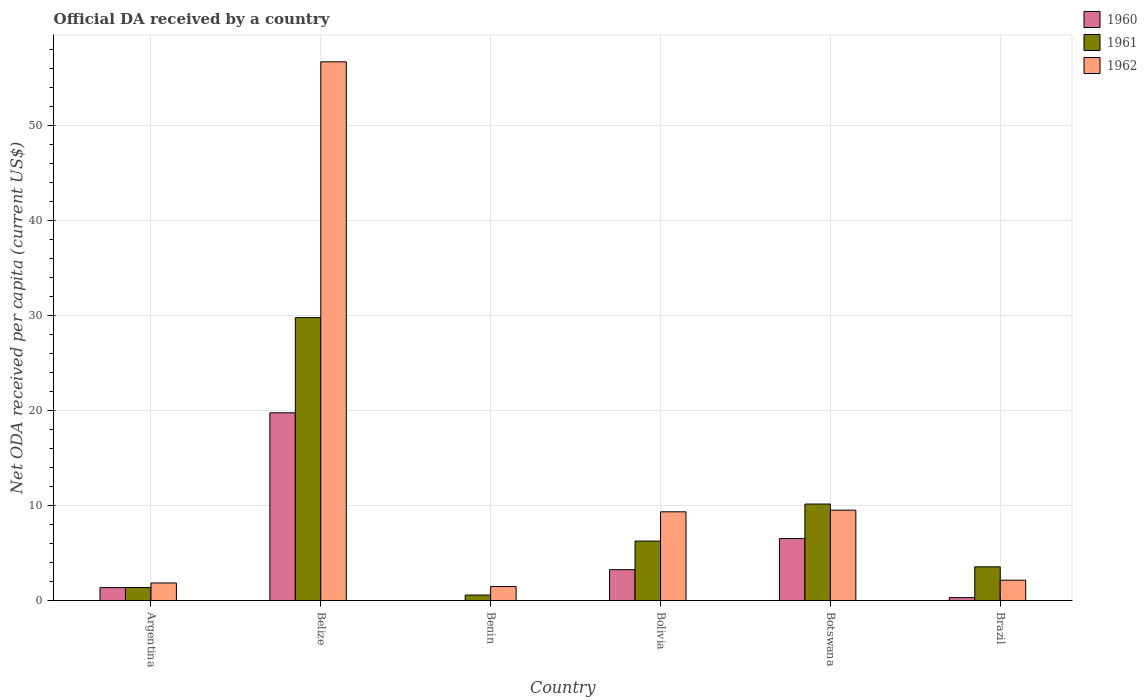Are the number of bars per tick equal to the number of legend labels?
Your answer should be compact. Yes. How many bars are there on the 6th tick from the left?
Provide a short and direct response. 3. What is the label of the 2nd group of bars from the left?
Make the answer very short. Belize. In how many cases, is the number of bars for a given country not equal to the number of legend labels?
Provide a short and direct response. 0. What is the ODA received in in 1961 in Botswana?
Offer a very short reply. 10.18. Across all countries, what is the maximum ODA received in in 1960?
Provide a short and direct response. 19.77. Across all countries, what is the minimum ODA received in in 1962?
Make the answer very short. 1.5. In which country was the ODA received in in 1960 maximum?
Your response must be concise. Belize. In which country was the ODA received in in 1961 minimum?
Your response must be concise. Benin. What is the total ODA received in in 1962 in the graph?
Keep it short and to the point. 81.09. What is the difference between the ODA received in in 1961 in Benin and that in Brazil?
Your answer should be compact. -2.97. What is the difference between the ODA received in in 1961 in Brazil and the ODA received in in 1960 in Bolivia?
Offer a very short reply. 0.3. What is the average ODA received in in 1960 per country?
Offer a very short reply. 5.22. What is the difference between the ODA received in of/in 1962 and ODA received in of/in 1960 in Brazil?
Give a very brief answer. 1.83. In how many countries, is the ODA received in in 1962 greater than 8 US$?
Offer a terse response. 3. What is the ratio of the ODA received in in 1962 in Benin to that in Brazil?
Keep it short and to the point. 0.69. Is the ODA received in in 1961 in Belize less than that in Brazil?
Make the answer very short. No. What is the difference between the highest and the second highest ODA received in in 1961?
Provide a short and direct response. -19.6. What is the difference between the highest and the lowest ODA received in in 1960?
Provide a succinct answer. 19.76. In how many countries, is the ODA received in in 1962 greater than the average ODA received in in 1962 taken over all countries?
Give a very brief answer. 1. Is the sum of the ODA received in in 1962 in Botswana and Brazil greater than the maximum ODA received in in 1960 across all countries?
Provide a succinct answer. No. What does the 3rd bar from the right in Botswana represents?
Provide a short and direct response. 1960. Is it the case that in every country, the sum of the ODA received in in 1961 and ODA received in in 1960 is greater than the ODA received in in 1962?
Provide a succinct answer. No. Are all the bars in the graph horizontal?
Make the answer very short. No. How many countries are there in the graph?
Keep it short and to the point. 6. What is the difference between two consecutive major ticks on the Y-axis?
Ensure brevity in your answer.  10. Are the values on the major ticks of Y-axis written in scientific E-notation?
Offer a very short reply. No. Does the graph contain any zero values?
Your answer should be compact. No. Where does the legend appear in the graph?
Keep it short and to the point. Top right. How many legend labels are there?
Ensure brevity in your answer.  3. What is the title of the graph?
Ensure brevity in your answer.  Official DA received by a country. Does "1975" appear as one of the legend labels in the graph?
Provide a succinct answer. No. What is the label or title of the Y-axis?
Give a very brief answer. Net ODA received per capita (current US$). What is the Net ODA received per capita (current US$) in 1960 in Argentina?
Provide a succinct answer. 1.39. What is the Net ODA received per capita (current US$) of 1961 in Argentina?
Keep it short and to the point. 1.39. What is the Net ODA received per capita (current US$) of 1962 in Argentina?
Offer a very short reply. 1.87. What is the Net ODA received per capita (current US$) of 1960 in Belize?
Provide a succinct answer. 19.77. What is the Net ODA received per capita (current US$) of 1961 in Belize?
Keep it short and to the point. 29.78. What is the Net ODA received per capita (current US$) in 1962 in Belize?
Keep it short and to the point. 56.68. What is the Net ODA received per capita (current US$) of 1960 in Benin?
Your answer should be compact. 0.01. What is the Net ODA received per capita (current US$) in 1961 in Benin?
Make the answer very short. 0.6. What is the Net ODA received per capita (current US$) in 1962 in Benin?
Offer a very short reply. 1.5. What is the Net ODA received per capita (current US$) of 1960 in Bolivia?
Your answer should be compact. 3.27. What is the Net ODA received per capita (current US$) in 1961 in Bolivia?
Provide a short and direct response. 6.28. What is the Net ODA received per capita (current US$) in 1962 in Bolivia?
Provide a succinct answer. 9.36. What is the Net ODA received per capita (current US$) in 1960 in Botswana?
Your answer should be compact. 6.55. What is the Net ODA received per capita (current US$) of 1961 in Botswana?
Make the answer very short. 10.18. What is the Net ODA received per capita (current US$) of 1962 in Botswana?
Provide a short and direct response. 9.53. What is the Net ODA received per capita (current US$) in 1960 in Brazil?
Offer a terse response. 0.33. What is the Net ODA received per capita (current US$) of 1961 in Brazil?
Provide a succinct answer. 3.57. What is the Net ODA received per capita (current US$) in 1962 in Brazil?
Provide a short and direct response. 2.16. Across all countries, what is the maximum Net ODA received per capita (current US$) of 1960?
Keep it short and to the point. 19.77. Across all countries, what is the maximum Net ODA received per capita (current US$) of 1961?
Offer a terse response. 29.78. Across all countries, what is the maximum Net ODA received per capita (current US$) in 1962?
Your answer should be compact. 56.68. Across all countries, what is the minimum Net ODA received per capita (current US$) in 1960?
Give a very brief answer. 0.01. Across all countries, what is the minimum Net ODA received per capita (current US$) of 1961?
Offer a very short reply. 0.6. Across all countries, what is the minimum Net ODA received per capita (current US$) in 1962?
Provide a succinct answer. 1.5. What is the total Net ODA received per capita (current US$) of 1960 in the graph?
Your response must be concise. 31.31. What is the total Net ODA received per capita (current US$) of 1961 in the graph?
Offer a terse response. 51.79. What is the total Net ODA received per capita (current US$) in 1962 in the graph?
Offer a very short reply. 81.09. What is the difference between the Net ODA received per capita (current US$) in 1960 in Argentina and that in Belize?
Offer a very short reply. -18.38. What is the difference between the Net ODA received per capita (current US$) of 1961 in Argentina and that in Belize?
Offer a terse response. -28.39. What is the difference between the Net ODA received per capita (current US$) of 1962 in Argentina and that in Belize?
Provide a short and direct response. -54.81. What is the difference between the Net ODA received per capita (current US$) in 1960 in Argentina and that in Benin?
Keep it short and to the point. 1.38. What is the difference between the Net ODA received per capita (current US$) of 1961 in Argentina and that in Benin?
Your answer should be compact. 0.79. What is the difference between the Net ODA received per capita (current US$) in 1962 in Argentina and that in Benin?
Provide a short and direct response. 0.37. What is the difference between the Net ODA received per capita (current US$) of 1960 in Argentina and that in Bolivia?
Your answer should be compact. -1.88. What is the difference between the Net ODA received per capita (current US$) of 1961 in Argentina and that in Bolivia?
Offer a terse response. -4.88. What is the difference between the Net ODA received per capita (current US$) in 1962 in Argentina and that in Bolivia?
Your answer should be very brief. -7.49. What is the difference between the Net ODA received per capita (current US$) in 1960 in Argentina and that in Botswana?
Your response must be concise. -5.16. What is the difference between the Net ODA received per capita (current US$) of 1961 in Argentina and that in Botswana?
Offer a very short reply. -8.78. What is the difference between the Net ODA received per capita (current US$) in 1962 in Argentina and that in Botswana?
Your answer should be very brief. -7.66. What is the difference between the Net ODA received per capita (current US$) of 1960 in Argentina and that in Brazil?
Provide a short and direct response. 1.05. What is the difference between the Net ODA received per capita (current US$) in 1961 in Argentina and that in Brazil?
Make the answer very short. -2.18. What is the difference between the Net ODA received per capita (current US$) in 1962 in Argentina and that in Brazil?
Your response must be concise. -0.29. What is the difference between the Net ODA received per capita (current US$) of 1960 in Belize and that in Benin?
Your response must be concise. 19.76. What is the difference between the Net ODA received per capita (current US$) of 1961 in Belize and that in Benin?
Keep it short and to the point. 29.18. What is the difference between the Net ODA received per capita (current US$) in 1962 in Belize and that in Benin?
Make the answer very short. 55.18. What is the difference between the Net ODA received per capita (current US$) of 1960 in Belize and that in Bolivia?
Offer a terse response. 16.5. What is the difference between the Net ODA received per capita (current US$) of 1961 in Belize and that in Bolivia?
Provide a succinct answer. 23.5. What is the difference between the Net ODA received per capita (current US$) of 1962 in Belize and that in Bolivia?
Provide a short and direct response. 47.32. What is the difference between the Net ODA received per capita (current US$) in 1960 in Belize and that in Botswana?
Offer a very short reply. 13.22. What is the difference between the Net ODA received per capita (current US$) of 1961 in Belize and that in Botswana?
Give a very brief answer. 19.6. What is the difference between the Net ODA received per capita (current US$) of 1962 in Belize and that in Botswana?
Make the answer very short. 47.15. What is the difference between the Net ODA received per capita (current US$) of 1960 in Belize and that in Brazil?
Offer a terse response. 19.44. What is the difference between the Net ODA received per capita (current US$) in 1961 in Belize and that in Brazil?
Your response must be concise. 26.21. What is the difference between the Net ODA received per capita (current US$) of 1962 in Belize and that in Brazil?
Offer a very short reply. 54.52. What is the difference between the Net ODA received per capita (current US$) in 1960 in Benin and that in Bolivia?
Ensure brevity in your answer.  -3.26. What is the difference between the Net ODA received per capita (current US$) in 1961 in Benin and that in Bolivia?
Provide a short and direct response. -5.68. What is the difference between the Net ODA received per capita (current US$) of 1962 in Benin and that in Bolivia?
Your answer should be very brief. -7.86. What is the difference between the Net ODA received per capita (current US$) in 1960 in Benin and that in Botswana?
Keep it short and to the point. -6.54. What is the difference between the Net ODA received per capita (current US$) of 1961 in Benin and that in Botswana?
Your answer should be very brief. -9.58. What is the difference between the Net ODA received per capita (current US$) in 1962 in Benin and that in Botswana?
Your answer should be very brief. -8.03. What is the difference between the Net ODA received per capita (current US$) of 1960 in Benin and that in Brazil?
Give a very brief answer. -0.32. What is the difference between the Net ODA received per capita (current US$) of 1961 in Benin and that in Brazil?
Offer a very short reply. -2.97. What is the difference between the Net ODA received per capita (current US$) of 1962 in Benin and that in Brazil?
Make the answer very short. -0.66. What is the difference between the Net ODA received per capita (current US$) of 1960 in Bolivia and that in Botswana?
Your answer should be compact. -3.27. What is the difference between the Net ODA received per capita (current US$) in 1961 in Bolivia and that in Botswana?
Ensure brevity in your answer.  -3.9. What is the difference between the Net ODA received per capita (current US$) in 1962 in Bolivia and that in Botswana?
Your answer should be very brief. -0.17. What is the difference between the Net ODA received per capita (current US$) in 1960 in Bolivia and that in Brazil?
Provide a succinct answer. 2.94. What is the difference between the Net ODA received per capita (current US$) of 1961 in Bolivia and that in Brazil?
Your answer should be compact. 2.71. What is the difference between the Net ODA received per capita (current US$) of 1962 in Bolivia and that in Brazil?
Provide a short and direct response. 7.19. What is the difference between the Net ODA received per capita (current US$) in 1960 in Botswana and that in Brazil?
Provide a short and direct response. 6.21. What is the difference between the Net ODA received per capita (current US$) of 1961 in Botswana and that in Brazil?
Provide a succinct answer. 6.61. What is the difference between the Net ODA received per capita (current US$) in 1962 in Botswana and that in Brazil?
Make the answer very short. 7.36. What is the difference between the Net ODA received per capita (current US$) of 1960 in Argentina and the Net ODA received per capita (current US$) of 1961 in Belize?
Provide a short and direct response. -28.39. What is the difference between the Net ODA received per capita (current US$) of 1960 in Argentina and the Net ODA received per capita (current US$) of 1962 in Belize?
Your answer should be very brief. -55.29. What is the difference between the Net ODA received per capita (current US$) of 1961 in Argentina and the Net ODA received per capita (current US$) of 1962 in Belize?
Your answer should be compact. -55.29. What is the difference between the Net ODA received per capita (current US$) in 1960 in Argentina and the Net ODA received per capita (current US$) in 1961 in Benin?
Provide a short and direct response. 0.79. What is the difference between the Net ODA received per capita (current US$) in 1960 in Argentina and the Net ODA received per capita (current US$) in 1962 in Benin?
Give a very brief answer. -0.11. What is the difference between the Net ODA received per capita (current US$) of 1961 in Argentina and the Net ODA received per capita (current US$) of 1962 in Benin?
Give a very brief answer. -0.11. What is the difference between the Net ODA received per capita (current US$) of 1960 in Argentina and the Net ODA received per capita (current US$) of 1961 in Bolivia?
Keep it short and to the point. -4.89. What is the difference between the Net ODA received per capita (current US$) of 1960 in Argentina and the Net ODA received per capita (current US$) of 1962 in Bolivia?
Keep it short and to the point. -7.97. What is the difference between the Net ODA received per capita (current US$) of 1961 in Argentina and the Net ODA received per capita (current US$) of 1962 in Bolivia?
Your answer should be very brief. -7.96. What is the difference between the Net ODA received per capita (current US$) of 1960 in Argentina and the Net ODA received per capita (current US$) of 1961 in Botswana?
Keep it short and to the point. -8.79. What is the difference between the Net ODA received per capita (current US$) of 1960 in Argentina and the Net ODA received per capita (current US$) of 1962 in Botswana?
Your response must be concise. -8.14. What is the difference between the Net ODA received per capita (current US$) of 1961 in Argentina and the Net ODA received per capita (current US$) of 1962 in Botswana?
Provide a succinct answer. -8.13. What is the difference between the Net ODA received per capita (current US$) in 1960 in Argentina and the Net ODA received per capita (current US$) in 1961 in Brazil?
Ensure brevity in your answer.  -2.18. What is the difference between the Net ODA received per capita (current US$) of 1960 in Argentina and the Net ODA received per capita (current US$) of 1962 in Brazil?
Make the answer very short. -0.78. What is the difference between the Net ODA received per capita (current US$) in 1961 in Argentina and the Net ODA received per capita (current US$) in 1962 in Brazil?
Keep it short and to the point. -0.77. What is the difference between the Net ODA received per capita (current US$) in 1960 in Belize and the Net ODA received per capita (current US$) in 1961 in Benin?
Provide a short and direct response. 19.17. What is the difference between the Net ODA received per capita (current US$) in 1960 in Belize and the Net ODA received per capita (current US$) in 1962 in Benin?
Provide a short and direct response. 18.27. What is the difference between the Net ODA received per capita (current US$) of 1961 in Belize and the Net ODA received per capita (current US$) of 1962 in Benin?
Offer a very short reply. 28.28. What is the difference between the Net ODA received per capita (current US$) in 1960 in Belize and the Net ODA received per capita (current US$) in 1961 in Bolivia?
Your answer should be very brief. 13.49. What is the difference between the Net ODA received per capita (current US$) of 1960 in Belize and the Net ODA received per capita (current US$) of 1962 in Bolivia?
Offer a very short reply. 10.41. What is the difference between the Net ODA received per capita (current US$) of 1961 in Belize and the Net ODA received per capita (current US$) of 1962 in Bolivia?
Provide a succinct answer. 20.42. What is the difference between the Net ODA received per capita (current US$) in 1960 in Belize and the Net ODA received per capita (current US$) in 1961 in Botswana?
Make the answer very short. 9.59. What is the difference between the Net ODA received per capita (current US$) of 1960 in Belize and the Net ODA received per capita (current US$) of 1962 in Botswana?
Your answer should be very brief. 10.24. What is the difference between the Net ODA received per capita (current US$) of 1961 in Belize and the Net ODA received per capita (current US$) of 1962 in Botswana?
Your answer should be compact. 20.25. What is the difference between the Net ODA received per capita (current US$) of 1960 in Belize and the Net ODA received per capita (current US$) of 1961 in Brazil?
Your answer should be compact. 16.2. What is the difference between the Net ODA received per capita (current US$) in 1960 in Belize and the Net ODA received per capita (current US$) in 1962 in Brazil?
Your answer should be very brief. 17.61. What is the difference between the Net ODA received per capita (current US$) of 1961 in Belize and the Net ODA received per capita (current US$) of 1962 in Brazil?
Your answer should be compact. 27.61. What is the difference between the Net ODA received per capita (current US$) of 1960 in Benin and the Net ODA received per capita (current US$) of 1961 in Bolivia?
Your answer should be compact. -6.27. What is the difference between the Net ODA received per capita (current US$) in 1960 in Benin and the Net ODA received per capita (current US$) in 1962 in Bolivia?
Make the answer very short. -9.35. What is the difference between the Net ODA received per capita (current US$) in 1961 in Benin and the Net ODA received per capita (current US$) in 1962 in Bolivia?
Offer a very short reply. -8.76. What is the difference between the Net ODA received per capita (current US$) of 1960 in Benin and the Net ODA received per capita (current US$) of 1961 in Botswana?
Ensure brevity in your answer.  -10.17. What is the difference between the Net ODA received per capita (current US$) of 1960 in Benin and the Net ODA received per capita (current US$) of 1962 in Botswana?
Keep it short and to the point. -9.52. What is the difference between the Net ODA received per capita (current US$) in 1961 in Benin and the Net ODA received per capita (current US$) in 1962 in Botswana?
Provide a short and direct response. -8.93. What is the difference between the Net ODA received per capita (current US$) of 1960 in Benin and the Net ODA received per capita (current US$) of 1961 in Brazil?
Give a very brief answer. -3.56. What is the difference between the Net ODA received per capita (current US$) of 1960 in Benin and the Net ODA received per capita (current US$) of 1962 in Brazil?
Keep it short and to the point. -2.15. What is the difference between the Net ODA received per capita (current US$) in 1961 in Benin and the Net ODA received per capita (current US$) in 1962 in Brazil?
Give a very brief answer. -1.56. What is the difference between the Net ODA received per capita (current US$) in 1960 in Bolivia and the Net ODA received per capita (current US$) in 1961 in Botswana?
Your answer should be compact. -6.91. What is the difference between the Net ODA received per capita (current US$) of 1960 in Bolivia and the Net ODA received per capita (current US$) of 1962 in Botswana?
Offer a terse response. -6.26. What is the difference between the Net ODA received per capita (current US$) of 1961 in Bolivia and the Net ODA received per capita (current US$) of 1962 in Botswana?
Provide a succinct answer. -3.25. What is the difference between the Net ODA received per capita (current US$) of 1960 in Bolivia and the Net ODA received per capita (current US$) of 1961 in Brazil?
Provide a short and direct response. -0.3. What is the difference between the Net ODA received per capita (current US$) of 1960 in Bolivia and the Net ODA received per capita (current US$) of 1962 in Brazil?
Ensure brevity in your answer.  1.11. What is the difference between the Net ODA received per capita (current US$) in 1961 in Bolivia and the Net ODA received per capita (current US$) in 1962 in Brazil?
Offer a very short reply. 4.11. What is the difference between the Net ODA received per capita (current US$) of 1960 in Botswana and the Net ODA received per capita (current US$) of 1961 in Brazil?
Your answer should be compact. 2.98. What is the difference between the Net ODA received per capita (current US$) of 1960 in Botswana and the Net ODA received per capita (current US$) of 1962 in Brazil?
Your answer should be compact. 4.38. What is the difference between the Net ODA received per capita (current US$) of 1961 in Botswana and the Net ODA received per capita (current US$) of 1962 in Brazil?
Your answer should be compact. 8.01. What is the average Net ODA received per capita (current US$) of 1960 per country?
Ensure brevity in your answer.  5.22. What is the average Net ODA received per capita (current US$) of 1961 per country?
Give a very brief answer. 8.63. What is the average Net ODA received per capita (current US$) in 1962 per country?
Your answer should be compact. 13.52. What is the difference between the Net ODA received per capita (current US$) in 1960 and Net ODA received per capita (current US$) in 1961 in Argentina?
Offer a terse response. -0.01. What is the difference between the Net ODA received per capita (current US$) of 1960 and Net ODA received per capita (current US$) of 1962 in Argentina?
Ensure brevity in your answer.  -0.48. What is the difference between the Net ODA received per capita (current US$) in 1961 and Net ODA received per capita (current US$) in 1962 in Argentina?
Offer a very short reply. -0.48. What is the difference between the Net ODA received per capita (current US$) of 1960 and Net ODA received per capita (current US$) of 1961 in Belize?
Offer a terse response. -10.01. What is the difference between the Net ODA received per capita (current US$) of 1960 and Net ODA received per capita (current US$) of 1962 in Belize?
Your answer should be compact. -36.91. What is the difference between the Net ODA received per capita (current US$) in 1961 and Net ODA received per capita (current US$) in 1962 in Belize?
Provide a short and direct response. -26.9. What is the difference between the Net ODA received per capita (current US$) in 1960 and Net ODA received per capita (current US$) in 1961 in Benin?
Provide a short and direct response. -0.59. What is the difference between the Net ODA received per capita (current US$) in 1960 and Net ODA received per capita (current US$) in 1962 in Benin?
Give a very brief answer. -1.49. What is the difference between the Net ODA received per capita (current US$) of 1961 and Net ODA received per capita (current US$) of 1962 in Benin?
Ensure brevity in your answer.  -0.9. What is the difference between the Net ODA received per capita (current US$) in 1960 and Net ODA received per capita (current US$) in 1961 in Bolivia?
Offer a very short reply. -3.01. What is the difference between the Net ODA received per capita (current US$) of 1960 and Net ODA received per capita (current US$) of 1962 in Bolivia?
Keep it short and to the point. -6.09. What is the difference between the Net ODA received per capita (current US$) in 1961 and Net ODA received per capita (current US$) in 1962 in Bolivia?
Make the answer very short. -3.08. What is the difference between the Net ODA received per capita (current US$) in 1960 and Net ODA received per capita (current US$) in 1961 in Botswana?
Give a very brief answer. -3.63. What is the difference between the Net ODA received per capita (current US$) in 1960 and Net ODA received per capita (current US$) in 1962 in Botswana?
Give a very brief answer. -2.98. What is the difference between the Net ODA received per capita (current US$) of 1961 and Net ODA received per capita (current US$) of 1962 in Botswana?
Give a very brief answer. 0.65. What is the difference between the Net ODA received per capita (current US$) of 1960 and Net ODA received per capita (current US$) of 1961 in Brazil?
Provide a short and direct response. -3.24. What is the difference between the Net ODA received per capita (current US$) of 1960 and Net ODA received per capita (current US$) of 1962 in Brazil?
Keep it short and to the point. -1.83. What is the difference between the Net ODA received per capita (current US$) of 1961 and Net ODA received per capita (current US$) of 1962 in Brazil?
Offer a terse response. 1.41. What is the ratio of the Net ODA received per capita (current US$) in 1960 in Argentina to that in Belize?
Provide a succinct answer. 0.07. What is the ratio of the Net ODA received per capita (current US$) of 1961 in Argentina to that in Belize?
Provide a succinct answer. 0.05. What is the ratio of the Net ODA received per capita (current US$) in 1962 in Argentina to that in Belize?
Ensure brevity in your answer.  0.03. What is the ratio of the Net ODA received per capita (current US$) of 1960 in Argentina to that in Benin?
Your answer should be compact. 168.52. What is the ratio of the Net ODA received per capita (current US$) of 1961 in Argentina to that in Benin?
Give a very brief answer. 2.32. What is the ratio of the Net ODA received per capita (current US$) in 1962 in Argentina to that in Benin?
Your answer should be compact. 1.25. What is the ratio of the Net ODA received per capita (current US$) of 1960 in Argentina to that in Bolivia?
Ensure brevity in your answer.  0.42. What is the ratio of the Net ODA received per capita (current US$) in 1961 in Argentina to that in Bolivia?
Offer a very short reply. 0.22. What is the ratio of the Net ODA received per capita (current US$) of 1962 in Argentina to that in Bolivia?
Keep it short and to the point. 0.2. What is the ratio of the Net ODA received per capita (current US$) of 1960 in Argentina to that in Botswana?
Ensure brevity in your answer.  0.21. What is the ratio of the Net ODA received per capita (current US$) of 1961 in Argentina to that in Botswana?
Your answer should be very brief. 0.14. What is the ratio of the Net ODA received per capita (current US$) in 1962 in Argentina to that in Botswana?
Your answer should be compact. 0.2. What is the ratio of the Net ODA received per capita (current US$) of 1960 in Argentina to that in Brazil?
Your response must be concise. 4.17. What is the ratio of the Net ODA received per capita (current US$) in 1961 in Argentina to that in Brazil?
Your answer should be very brief. 0.39. What is the ratio of the Net ODA received per capita (current US$) of 1962 in Argentina to that in Brazil?
Offer a terse response. 0.86. What is the ratio of the Net ODA received per capita (current US$) in 1960 in Belize to that in Benin?
Your answer should be very brief. 2403.41. What is the ratio of the Net ODA received per capita (current US$) of 1961 in Belize to that in Benin?
Your answer should be compact. 49.62. What is the ratio of the Net ODA received per capita (current US$) in 1962 in Belize to that in Benin?
Offer a very short reply. 37.84. What is the ratio of the Net ODA received per capita (current US$) in 1960 in Belize to that in Bolivia?
Your answer should be compact. 6.04. What is the ratio of the Net ODA received per capita (current US$) in 1961 in Belize to that in Bolivia?
Give a very brief answer. 4.74. What is the ratio of the Net ODA received per capita (current US$) in 1962 in Belize to that in Bolivia?
Make the answer very short. 6.06. What is the ratio of the Net ODA received per capita (current US$) of 1960 in Belize to that in Botswana?
Your response must be concise. 3.02. What is the ratio of the Net ODA received per capita (current US$) in 1961 in Belize to that in Botswana?
Make the answer very short. 2.93. What is the ratio of the Net ODA received per capita (current US$) in 1962 in Belize to that in Botswana?
Provide a short and direct response. 5.95. What is the ratio of the Net ODA received per capita (current US$) of 1960 in Belize to that in Brazil?
Provide a short and direct response. 59.44. What is the ratio of the Net ODA received per capita (current US$) in 1961 in Belize to that in Brazil?
Provide a short and direct response. 8.35. What is the ratio of the Net ODA received per capita (current US$) in 1962 in Belize to that in Brazil?
Ensure brevity in your answer.  26.21. What is the ratio of the Net ODA received per capita (current US$) of 1960 in Benin to that in Bolivia?
Your answer should be compact. 0. What is the ratio of the Net ODA received per capita (current US$) in 1961 in Benin to that in Bolivia?
Your answer should be compact. 0.1. What is the ratio of the Net ODA received per capita (current US$) in 1962 in Benin to that in Bolivia?
Make the answer very short. 0.16. What is the ratio of the Net ODA received per capita (current US$) in 1960 in Benin to that in Botswana?
Provide a short and direct response. 0. What is the ratio of the Net ODA received per capita (current US$) of 1961 in Benin to that in Botswana?
Ensure brevity in your answer.  0.06. What is the ratio of the Net ODA received per capita (current US$) of 1962 in Benin to that in Botswana?
Provide a short and direct response. 0.16. What is the ratio of the Net ODA received per capita (current US$) in 1960 in Benin to that in Brazil?
Offer a terse response. 0.02. What is the ratio of the Net ODA received per capita (current US$) of 1961 in Benin to that in Brazil?
Your answer should be compact. 0.17. What is the ratio of the Net ODA received per capita (current US$) in 1962 in Benin to that in Brazil?
Provide a short and direct response. 0.69. What is the ratio of the Net ODA received per capita (current US$) in 1960 in Bolivia to that in Botswana?
Provide a succinct answer. 0.5. What is the ratio of the Net ODA received per capita (current US$) in 1961 in Bolivia to that in Botswana?
Offer a very short reply. 0.62. What is the ratio of the Net ODA received per capita (current US$) in 1962 in Bolivia to that in Botswana?
Provide a succinct answer. 0.98. What is the ratio of the Net ODA received per capita (current US$) in 1960 in Bolivia to that in Brazil?
Provide a succinct answer. 9.83. What is the ratio of the Net ODA received per capita (current US$) in 1961 in Bolivia to that in Brazil?
Offer a terse response. 1.76. What is the ratio of the Net ODA received per capita (current US$) of 1962 in Bolivia to that in Brazil?
Your response must be concise. 4.33. What is the ratio of the Net ODA received per capita (current US$) in 1960 in Botswana to that in Brazil?
Give a very brief answer. 19.68. What is the ratio of the Net ODA received per capita (current US$) in 1961 in Botswana to that in Brazil?
Keep it short and to the point. 2.85. What is the ratio of the Net ODA received per capita (current US$) in 1962 in Botswana to that in Brazil?
Your answer should be very brief. 4.4. What is the difference between the highest and the second highest Net ODA received per capita (current US$) of 1960?
Your answer should be compact. 13.22. What is the difference between the highest and the second highest Net ODA received per capita (current US$) of 1961?
Offer a terse response. 19.6. What is the difference between the highest and the second highest Net ODA received per capita (current US$) in 1962?
Ensure brevity in your answer.  47.15. What is the difference between the highest and the lowest Net ODA received per capita (current US$) of 1960?
Offer a terse response. 19.76. What is the difference between the highest and the lowest Net ODA received per capita (current US$) in 1961?
Your response must be concise. 29.18. What is the difference between the highest and the lowest Net ODA received per capita (current US$) of 1962?
Your answer should be very brief. 55.18. 